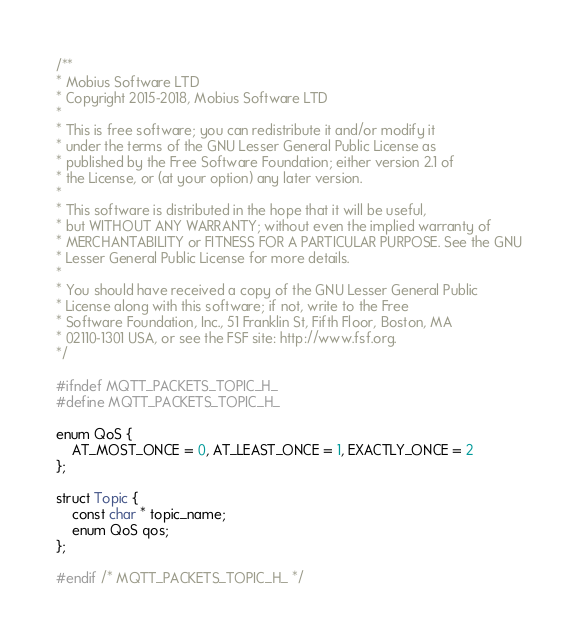<code> <loc_0><loc_0><loc_500><loc_500><_C_>/**
* Mobius Software LTD
* Copyright 2015-2018, Mobius Software LTD
*
* This is free software; you can redistribute it and/or modify it
* under the terms of the GNU Lesser General Public License as
* published by the Free Software Foundation; either version 2.1 of
* the License, or (at your option) any later version.
*
* This software is distributed in the hope that it will be useful,
* but WITHOUT ANY WARRANTY; without even the implied warranty of
* MERCHANTABILITY or FITNESS FOR A PARTICULAR PURPOSE. See the GNU
* Lesser General Public License for more details.
*
* You should have received a copy of the GNU Lesser General Public
* License along with this software; if not, write to the Free
* Software Foundation, Inc., 51 Franklin St, Fifth Floor, Boston, MA
* 02110-1301 USA, or see the FSF site: http://www.fsf.org.
*/

#ifndef MQTT_PACKETS_TOPIC_H_
#define MQTT_PACKETS_TOPIC_H_

enum QoS {
	AT_MOST_ONCE = 0, AT_LEAST_ONCE = 1, EXACTLY_ONCE = 2
};

struct Topic {
	const char * topic_name;
	enum QoS qos;
};

#endif /* MQTT_PACKETS_TOPIC_H_ */
</code> 